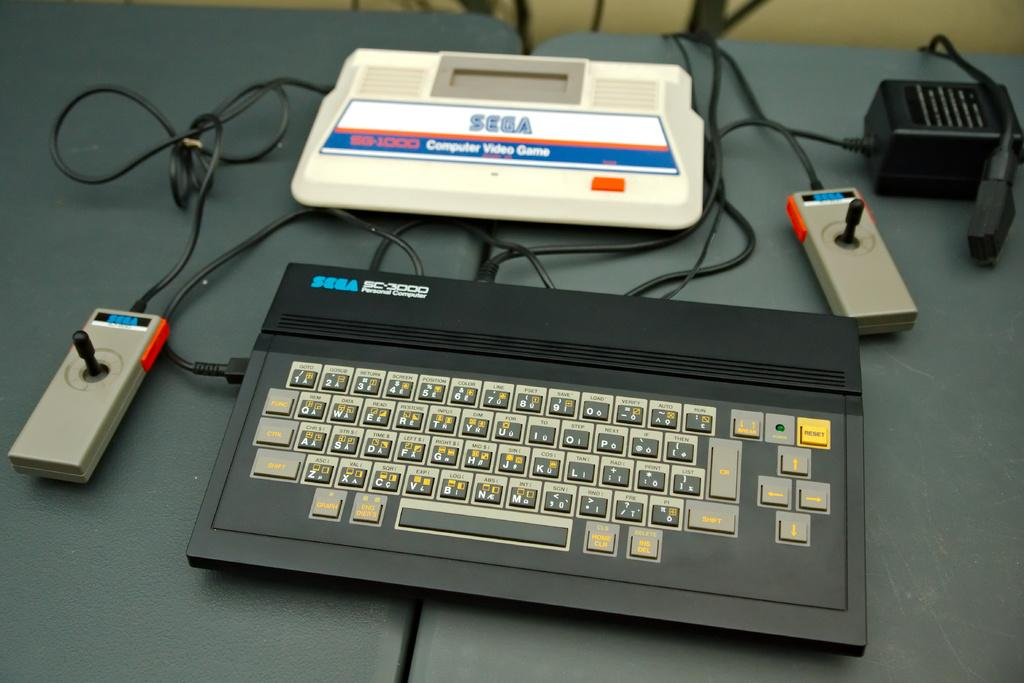What is the main object in the center of the image? There is a platform in the center of the image. What is placed on the platform? A keyboard is present on the platform. Are there any additional items on the platform? Yes, there are some objects on the platform. What can be seen in the background of the image? There is a wall in the background of the image. Can you see a monkey holding an umbrella on the platform in the image? No, there is no monkey or umbrella present on the platform in the image. 